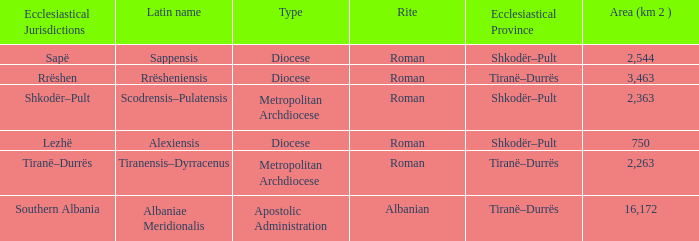What Ecclesiastical Province has a type diocese and a latin name alexiensis? Shkodër–Pult. Could you parse the entire table? {'header': ['Ecclesiastical Jurisdictions', 'Latin name', 'Type', 'Rite', 'Ecclesiastical Province', 'Area (km 2 )'], 'rows': [['Sapë', 'Sappensis', 'Diocese', 'Roman', 'Shkodër–Pult', '2,544'], ['Rrëshen', 'Rrësheniensis', 'Diocese', 'Roman', 'Tiranë–Durrës', '3,463'], ['Shkodër–Pult', 'Scodrensis–Pulatensis', 'Metropolitan Archdiocese', 'Roman', 'Shkodër–Pult', '2,363'], ['Lezhë', 'Alexiensis', 'Diocese', 'Roman', 'Shkodër–Pult', '750'], ['Tiranë–Durrës', 'Tiranensis–Dyrracenus', 'Metropolitan Archdiocese', 'Roman', 'Tiranë–Durrës', '2,263'], ['Southern Albania', 'Albaniae Meridionalis', 'Apostolic Administration', 'Albanian', 'Tiranë–Durrës', '16,172']]} 